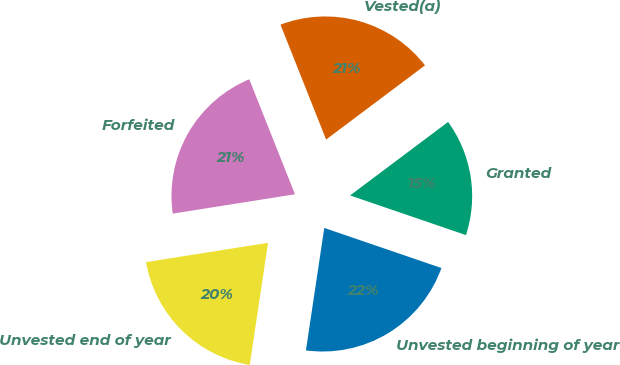Convert chart. <chart><loc_0><loc_0><loc_500><loc_500><pie_chart><fcel>Unvested beginning of year<fcel>Granted<fcel>Vested(a)<fcel>Forfeited<fcel>Unvested end of year<nl><fcel>22.12%<fcel>15.49%<fcel>20.78%<fcel>21.48%<fcel>20.14%<nl></chart> 